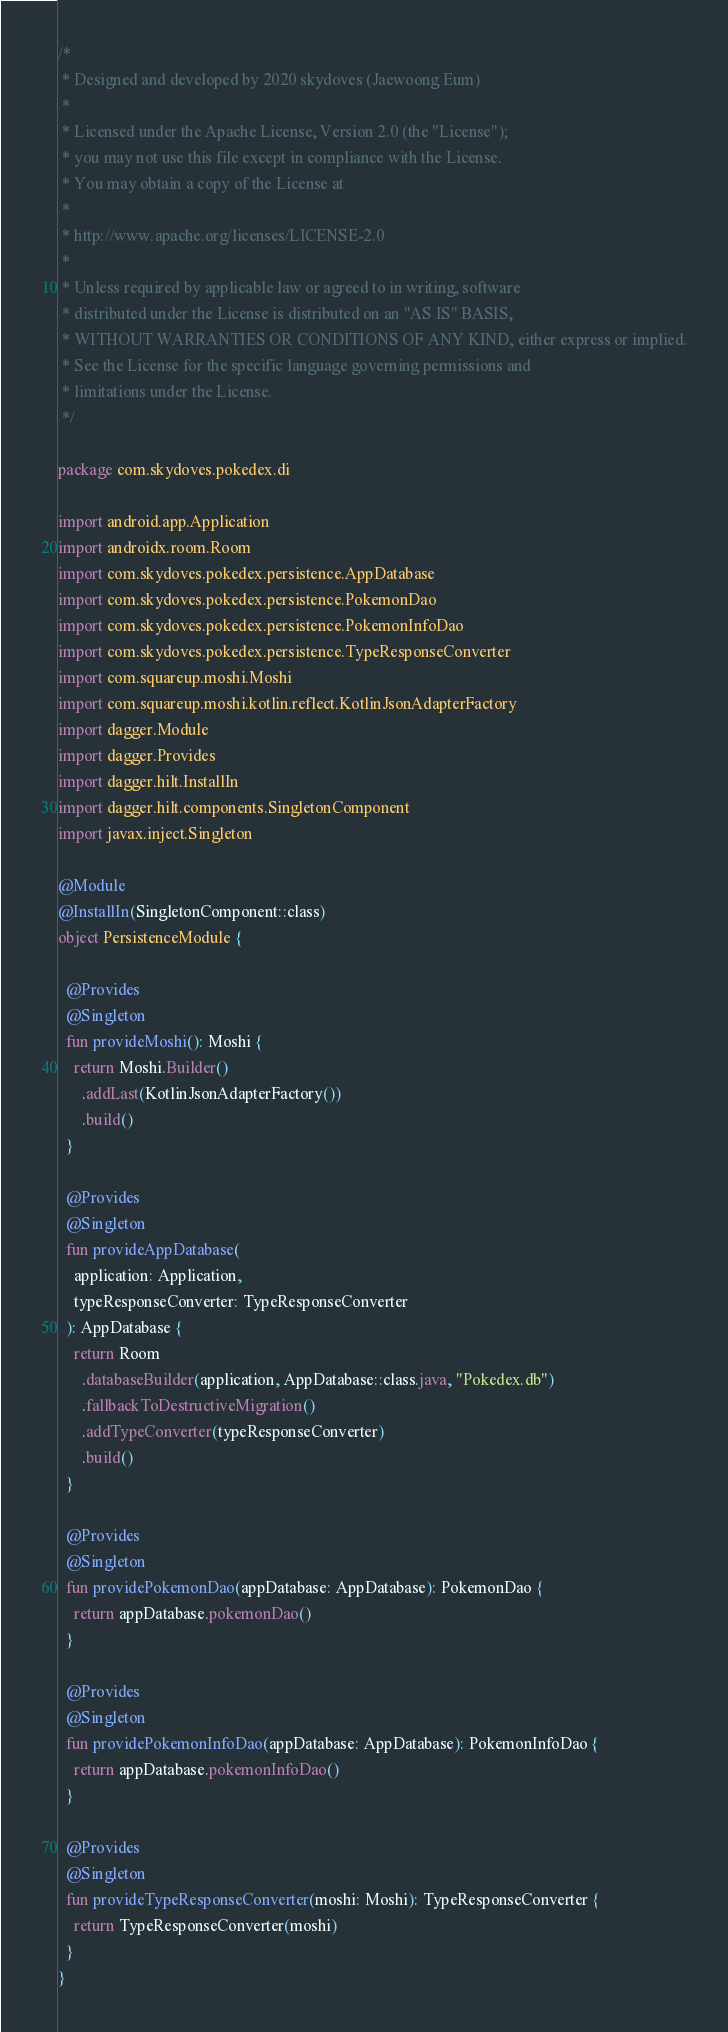Convert code to text. <code><loc_0><loc_0><loc_500><loc_500><_Kotlin_>/*
 * Designed and developed by 2020 skydoves (Jaewoong Eum)
 *
 * Licensed under the Apache License, Version 2.0 (the "License");
 * you may not use this file except in compliance with the License.
 * You may obtain a copy of the License at
 *
 * http://www.apache.org/licenses/LICENSE-2.0
 *
 * Unless required by applicable law or agreed to in writing, software
 * distributed under the License is distributed on an "AS IS" BASIS,
 * WITHOUT WARRANTIES OR CONDITIONS OF ANY KIND, either express or implied.
 * See the License for the specific language governing permissions and
 * limitations under the License.
 */

package com.skydoves.pokedex.di

import android.app.Application
import androidx.room.Room
import com.skydoves.pokedex.persistence.AppDatabase
import com.skydoves.pokedex.persistence.PokemonDao
import com.skydoves.pokedex.persistence.PokemonInfoDao
import com.skydoves.pokedex.persistence.TypeResponseConverter
import com.squareup.moshi.Moshi
import com.squareup.moshi.kotlin.reflect.KotlinJsonAdapterFactory
import dagger.Module
import dagger.Provides
import dagger.hilt.InstallIn
import dagger.hilt.components.SingletonComponent
import javax.inject.Singleton

@Module
@InstallIn(SingletonComponent::class)
object PersistenceModule {

  @Provides
  @Singleton
  fun provideMoshi(): Moshi {
    return Moshi.Builder()
      .addLast(KotlinJsonAdapterFactory())
      .build()
  }

  @Provides
  @Singleton
  fun provideAppDatabase(
    application: Application,
    typeResponseConverter: TypeResponseConverter
  ): AppDatabase {
    return Room
      .databaseBuilder(application, AppDatabase::class.java, "Pokedex.db")
      .fallbackToDestructiveMigration()
      .addTypeConverter(typeResponseConverter)
      .build()
  }

  @Provides
  @Singleton
  fun providePokemonDao(appDatabase: AppDatabase): PokemonDao {
    return appDatabase.pokemonDao()
  }

  @Provides
  @Singleton
  fun providePokemonInfoDao(appDatabase: AppDatabase): PokemonInfoDao {
    return appDatabase.pokemonInfoDao()
  }

  @Provides
  @Singleton
  fun provideTypeResponseConverter(moshi: Moshi): TypeResponseConverter {
    return TypeResponseConverter(moshi)
  }
}
</code> 